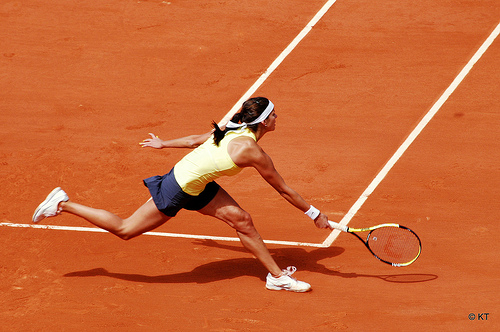How does that head band look, white or black? The headband appears to be distinctly white. 